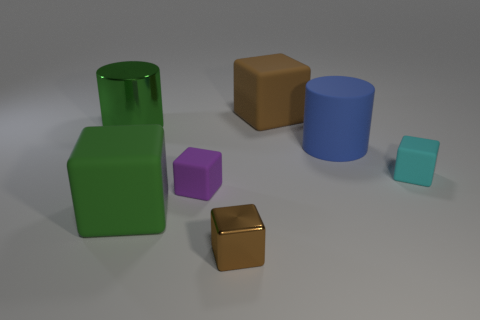What size is the metallic object on the right side of the green metallic cylinder that is in front of the big brown cube?
Provide a succinct answer. Small. What number of large objects are blue rubber things or cyan shiny spheres?
Your answer should be compact. 1. What number of other things are the same color as the rubber cylinder?
Offer a terse response. 0. Does the cylinder that is to the left of the large brown thing have the same size as the thing that is in front of the big green matte cube?
Ensure brevity in your answer.  No. Is the material of the large brown cube the same as the large cube that is on the left side of the tiny brown metal cube?
Make the answer very short. Yes. Is the number of blue matte cylinders on the left side of the big brown rubber thing greater than the number of green rubber things to the right of the small purple object?
Offer a terse response. No. There is a big block that is behind the large matte block in front of the big blue matte object; what color is it?
Make the answer very short. Brown. What number of spheres are matte objects or blue objects?
Provide a succinct answer. 0. How many brown blocks are both behind the large green matte cube and in front of the green matte thing?
Your answer should be compact. 0. What color is the big matte thing that is left of the large brown rubber cube?
Ensure brevity in your answer.  Green. 